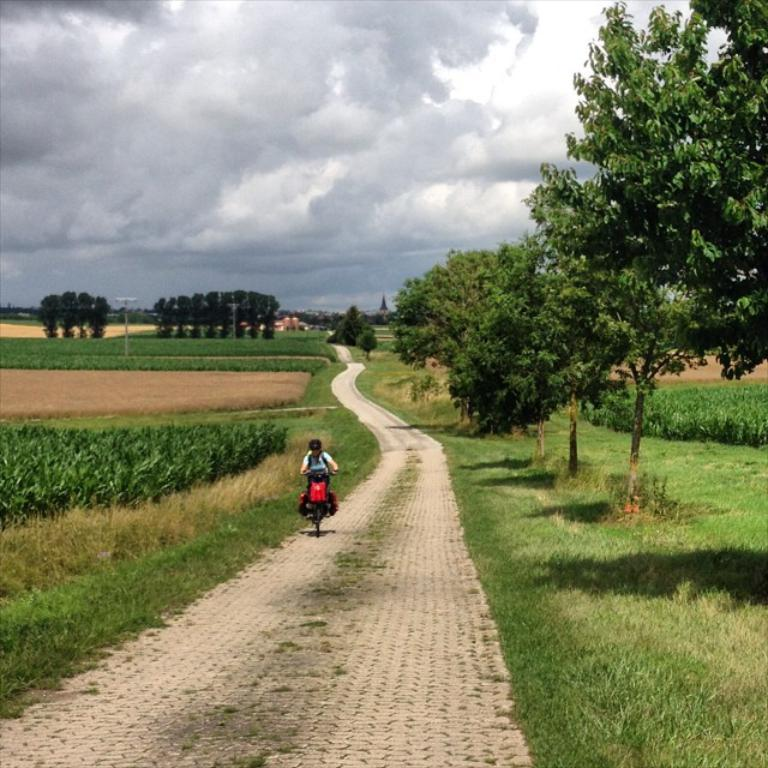What is the person in the image doing? There is a person riding a vehicle in the image. What type of environment is visible in the image? There is grass, plants, and trees visible in the image. Can you describe the background of the image? In the background, there are trees and a pole, with the sky visible and clouds present. What is the opinion of the person's mom about the pain they are experiencing in the image? There is no indication of pain or a mom's opinion in the image; it simply shows a person riding a vehicle in a natural environment. 